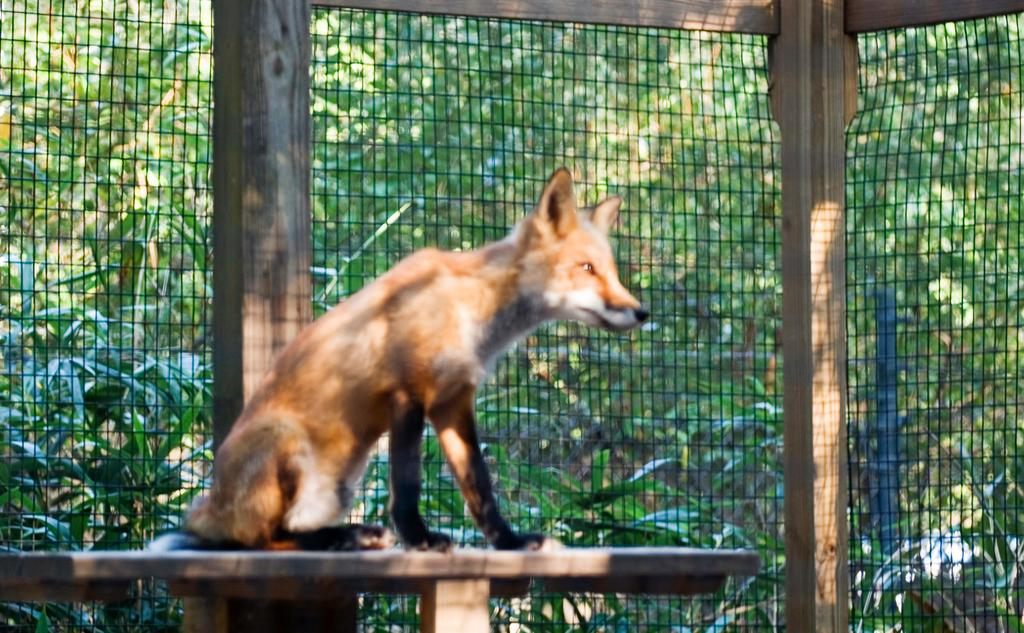What animal can be seen in the image? There is a dog in the image. Where is the dog located? The dog is sitting on a wooden table. What type of structure is present in the image? There is a fence in the image. How is the fence supported? The fence is attached to wooden poles. What can be seen through the fence? Trees are visible through the fence. What is the dog's opinion on the upcoming vacation? The image does not provide any information about the dog's opinion on a vacation, as it only shows the dog sitting on a wooden table and the presence of a fence and trees. 